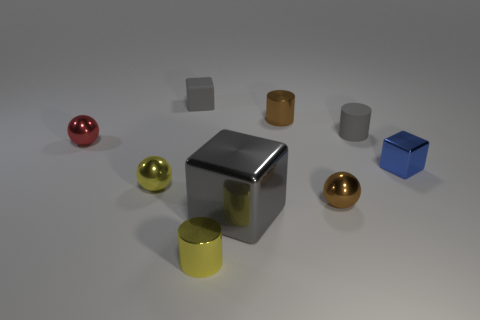There is a tiny rubber object that is the same color as the small rubber block; what is its shape?
Keep it short and to the point. Cylinder. Is the size of the red thing the same as the gray cube that is in front of the tiny matte cube?
Your response must be concise. No. What color is the tiny object that is both behind the tiny gray cylinder and in front of the small rubber cube?
Your answer should be very brief. Brown. Is the number of small shiny balls that are to the left of the gray metallic object greater than the number of gray blocks in front of the tiny blue shiny cube?
Give a very brief answer. Yes. There is a brown cylinder that is the same material as the red sphere; what is its size?
Offer a terse response. Small. There is a tiny red metallic ball in front of the gray rubber cylinder; what number of metal cylinders are behind it?
Your answer should be compact. 1. Are there any tiny blue things that have the same shape as the large metallic object?
Your response must be concise. Yes. There is a matte object to the right of the gray object that is in front of the small red metal sphere; what is its color?
Provide a short and direct response. Gray. Are there more tiny purple things than blue shiny objects?
Make the answer very short. No. How many blue blocks are the same size as the red metallic sphere?
Offer a very short reply. 1. 